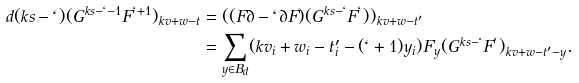<formula> <loc_0><loc_0><loc_500><loc_500>d ( k s - \ell ) ( G ^ { k s - \ell - 1 } F ^ { \ell + 1 } ) _ { k v + w - t } & = ( ( F \partial - \ell \partial F ) ( G ^ { k s - \ell } F ^ { \ell } ) ) _ { k v + w - t ^ { \prime } } \\ & = \sum _ { y \in B _ { d } } ( k v _ { i } + w _ { i } - t ^ { \prime } _ { i } - ( \ell + 1 ) y _ { i } ) F _ { y } ( G ^ { k s - \ell } F ^ { \ell } ) _ { k v + w - t ^ { \prime } - y } .</formula> 